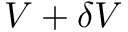<formula> <loc_0><loc_0><loc_500><loc_500>V + \delta V</formula> 